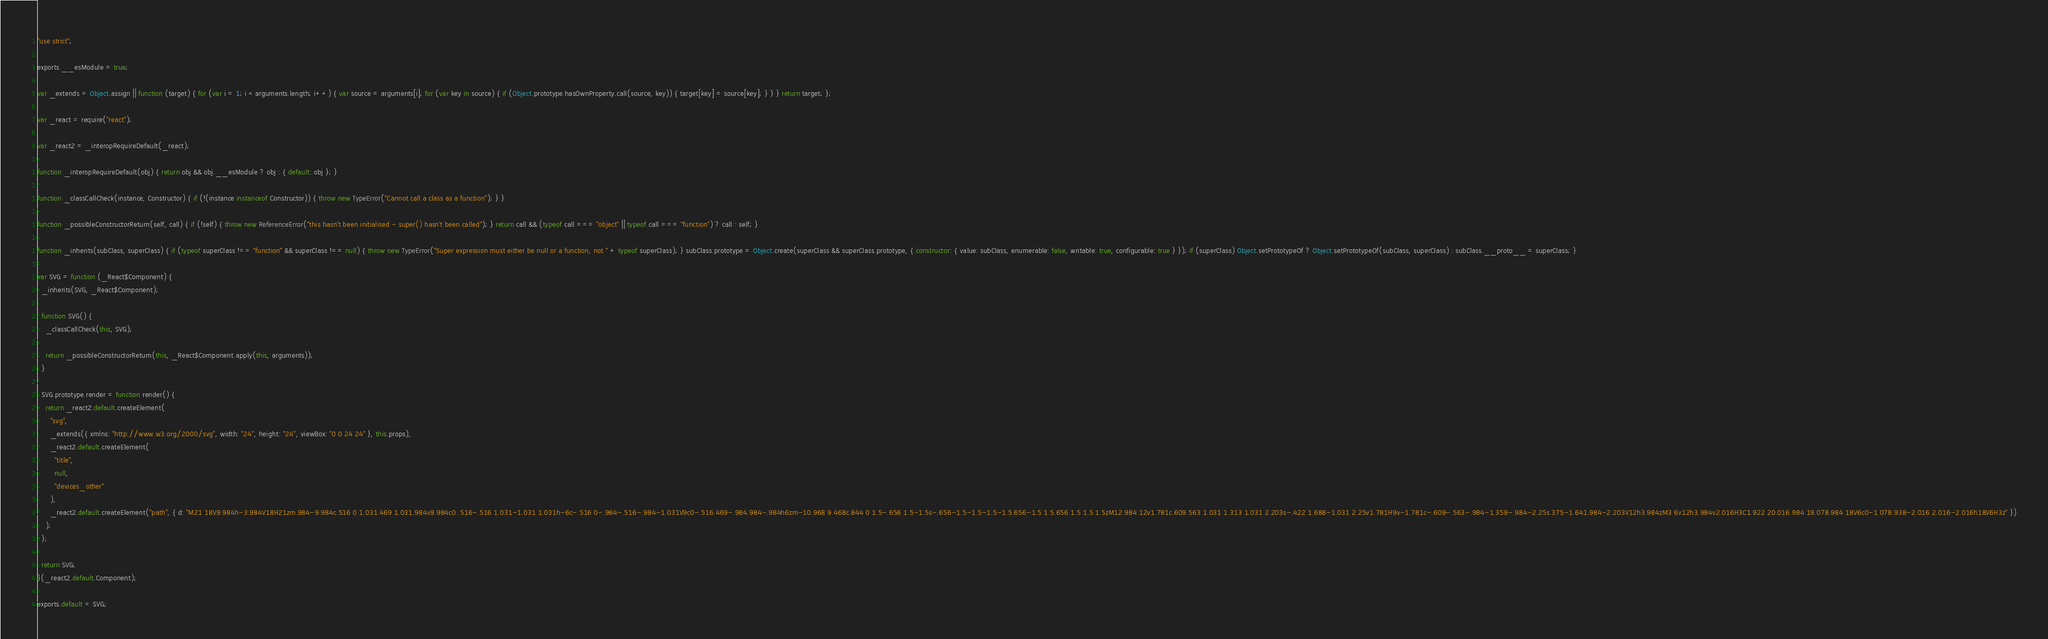Convert code to text. <code><loc_0><loc_0><loc_500><loc_500><_JavaScript_>"use strict";

exports.__esModule = true;

var _extends = Object.assign || function (target) { for (var i = 1; i < arguments.length; i++) { var source = arguments[i]; for (var key in source) { if (Object.prototype.hasOwnProperty.call(source, key)) { target[key] = source[key]; } } } return target; };

var _react = require("react");

var _react2 = _interopRequireDefault(_react);

function _interopRequireDefault(obj) { return obj && obj.__esModule ? obj : { default: obj }; }

function _classCallCheck(instance, Constructor) { if (!(instance instanceof Constructor)) { throw new TypeError("Cannot call a class as a function"); } }

function _possibleConstructorReturn(self, call) { if (!self) { throw new ReferenceError("this hasn't been initialised - super() hasn't been called"); } return call && (typeof call === "object" || typeof call === "function") ? call : self; }

function _inherits(subClass, superClass) { if (typeof superClass !== "function" && superClass !== null) { throw new TypeError("Super expression must either be null or a function, not " + typeof superClass); } subClass.prototype = Object.create(superClass && superClass.prototype, { constructor: { value: subClass, enumerable: false, writable: true, configurable: true } }); if (superClass) Object.setPrototypeOf ? Object.setPrototypeOf(subClass, superClass) : subClass.__proto__ = superClass; }

var SVG = function (_React$Component) {
  _inherits(SVG, _React$Component);

  function SVG() {
    _classCallCheck(this, SVG);

    return _possibleConstructorReturn(this, _React$Component.apply(this, arguments));
  }

  SVG.prototype.render = function render() {
    return _react2.default.createElement(
      "svg",
      _extends({ xmlns: "http://www.w3.org/2000/svg", width: "24", height: "24", viewBox: "0 0 24 24" }, this.props),
      _react2.default.createElement(
        "title",
        null,
        "devices_other"
      ),
      _react2.default.createElement("path", { d: "M21 18V9.984h-3.984V18H21zm.984-9.984c.516 0 1.031.469 1.031.984v9.984c0 .516-.516 1.031-1.031 1.031h-6c-.516 0-.984-.516-.984-1.031V9c0-.516.469-.984.984-.984h6zm-10.968 9.468c.844 0 1.5-.656 1.5-1.5s-.656-1.5-1.5-1.5-1.5.656-1.5 1.5.656 1.5 1.5 1.5zM12.984 12v1.781c.609.563 1.031 1.313 1.031 2.203s-.422 1.688-1.031 2.25v1.781H9v-1.781c-.609-.563-.984-1.359-.984-2.25s.375-1.641.984-2.203V12h3.984zM3 6v12h3.984v2.016H3C1.922 20.016.984 19.078.984 18V6c0-1.078.938-2.016 2.016-2.016h18V6H3z" })
    );
  };

  return SVG;
}(_react2.default.Component);

exports.default = SVG;</code> 